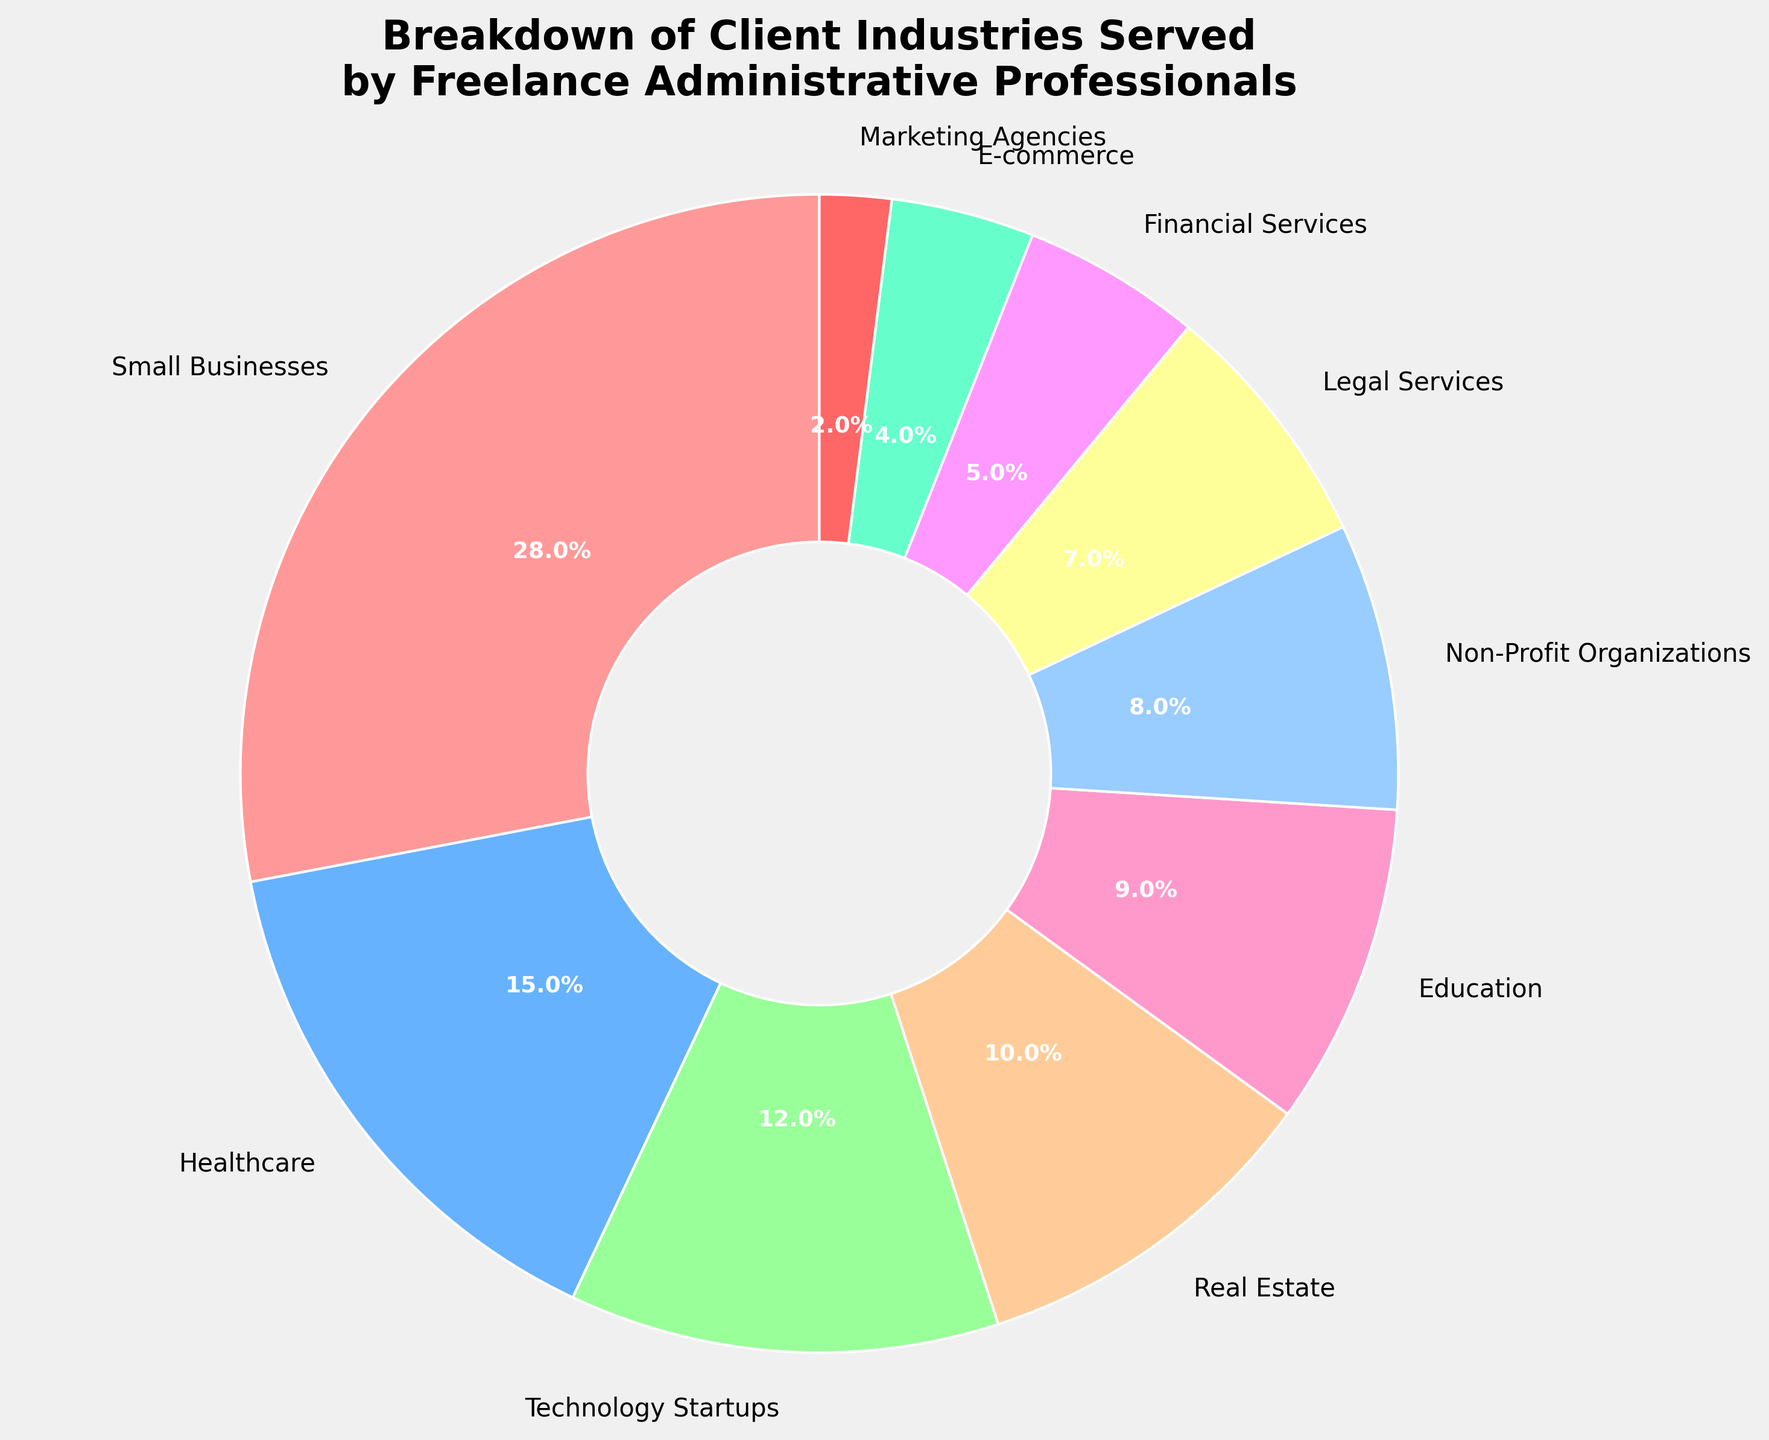What's the largest industry served by freelance administrative professionals? The pie chart indicates that Small Businesses occupy the largest segment with a percentage of 28%.
Answer: Small Businesses Which two industries combined make up the smallest percentage of the total? The two smallest segments visible in the pie chart are Marketing Agencies with 2% and E-commerce with 4%. Adding these two, 2% + 4% = 6%, making them the smallest combined total.
Answer: Marketing Agencies and E-commerce Are there more freelance administrative professionals serving Healthcare or Technology Startups? The chart shows Healthcare at 15% and Technology Startups at 12%. Since 15% is greater than 12%, there are more serving Healthcare.
Answer: Healthcare How much larger is the percentage of Small Businesses compared to Financial Services? The percentage for Small Businesses is 28%, and for Financial Services, it is 5%. Subtracting these, 28% - 5% = 23%.
Answer: 23% Which industry occupies the central pink section of the donut chart? By noting the color associations in the pie chart, the central pink section corresponds to Healthcare which is 15%.
Answer: Healthcare What is the total percentage of industries that make up more than 10% each? Summing the relevant percentages: Small Businesses (28%), Healthcare (15%), Technology Startups (12%), and Real Estate (10%) gives us 28% + 15% + 12% + 10% = 65%.
Answer: 65% Which color represents Legal Services on the chart? Based on the colors specified and observing the visual chart, Legal Services appear to be represented by light blue.
Answer: light blue Are Non-Profit Organizations served by a higher percentage of freelance administrative professionals than Education? The chart shows Non-Profit Organizations at 8% and Education at 9%. Since 9% is greater than 8%, Education is served by a higher percentage.
Answer: No What's the difference in percentage points between the second largest and the second smallest industry segments? Healthcare is the second largest at 15% and Financial Services is the second smallest at 5%. The difference is 15% - 5% = 10%.
Answer: 10% Which two industries together make up the largest portion of the chart? The largest two industries are Small Businesses (28%) and Healthcare (15%). Summing these gives 28% + 15% = 43%.
Answer: Small Businesses and Healthcare 